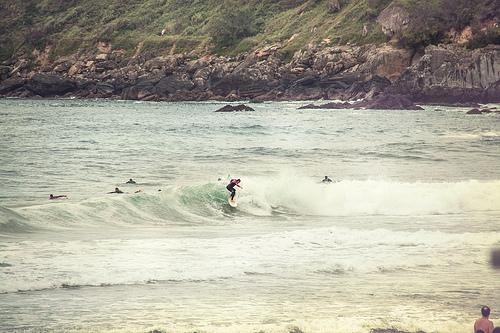What are some of the main objects found in the image that hint at the landscape type or geographic location? The main objects that hint at the landscape type are water, rocks, grass, and a coastline; these suggest a beach or coastal environment. How would you describe the quality of the image, considering the attention to details and the variety of objects depicted? The image quality is high due to the detailed description of objects, their positions, sizes, and the various activities taking place. Analyze the relationships between objects and people in the image, detailing any interactions or notable connections. People are interacting with objects like surfboards and water, engaging in activities like surfing and swimming; rocks and grass provide the backdrop, enhancing the beauty and enjoyment of the scene. Find the number of people and water instances present in the image and mention their activities. There are 9 people enjoying activities such as swimming, surfing, or watching; and 12 instances of water, including waves and different viewpoints. Discuss the emotions and sentiments that the image might evoke in the viewer. The image evokes feelings of relaxation, adventure, and enjoyment, as people are engaging in outdoor activities, having fun, and appreciating nature. Give a detailed explanation of the image focused on the main objects and surroundings. The image showcases a beach scene where multiple people are enjoying activities like surfing and swimming, surrounded by rocks, grass, and waves crashing against the shore. Identify the primary activity taking place in the image and mention the key objects involved. People are enjoying their time at the beach with activities like swimming and surfing; prominent objects include water, rocks, and surfboards. Estimate the number of people who are actively participating in water-based activities in the image. Around 7 people are actively participating in water-based activities such as swimming, surfing, or paddling. Enumerate the types of objects or elements present in the image that contribute to the overall ambiance. Water, rocks, grass, people, surfboards, and a beach setting create the overall ambiance. Is the man with the pink shirt riding a wave at X:232 Y:178 Width:12 Height:12? The coordinate and size refer to the "pink on the shirt", which only suggests a portion of a person's clothing, not the whole person nor the act of riding a wave. Are there any rocks floating above the waterline at X:210 Y:90 Width:45 Height:45? The coordinate and size refer to "rocks above the waterline"; nevertheless, rocks usually do not float as the instruction suggests. Is there a balding man surfing on a white surfboard at X:479 Y:302 Width:10 Height:10? The coordinate and size refer to a "balding man", but it does not mention anything about a surfboard or the act of surfing. Is a person enjoying the beach by standing on their head at X:460 Y:290 Width:35 Height:35? The coordinate and size refer to a "person enjoying the beach", but there's no information suggesting that the person is standing on their head. Can you see a group of people skating in water at X:30 Y:90 Width:465 Height:465? The coordinate and size refer to a "group of people skating in water", which is an uncommon and unlikely scenario since people usually do not skate in water. Can you find a person swimming in the grass on the hillside at X:137 Y:9 Width:225 Height:225? The coordinate and size refer to "grass on the hillside", and it does not imply any person or the action of swimming. 